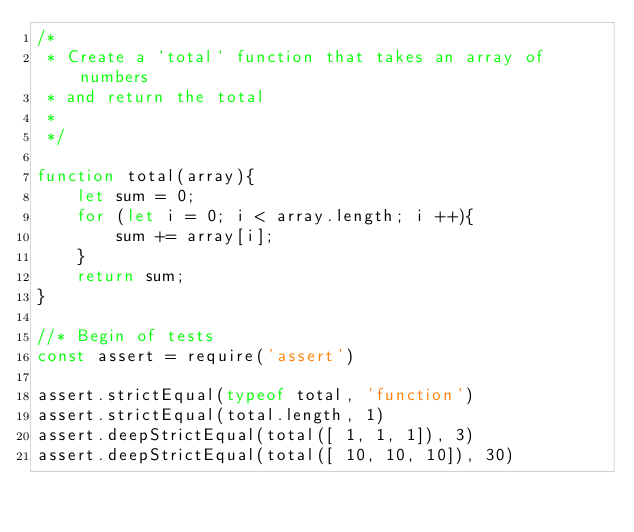Convert code to text. <code><loc_0><loc_0><loc_500><loc_500><_JavaScript_>/*
 * Create a `total` function that takes an array of numbers
 * and return the total
 *
 */

function total(array){
    let sum = 0;
    for (let i = 0; i < array.length; i ++){
        sum += array[i];
    }
    return sum;
} 

//* Begin of tests
const assert = require('assert')

assert.strictEqual(typeof total, 'function')
assert.strictEqual(total.length, 1)
assert.deepStrictEqual(total([ 1, 1, 1]), 3)
assert.deepStrictEqual(total([ 10, 10, 10]), 30)</code> 